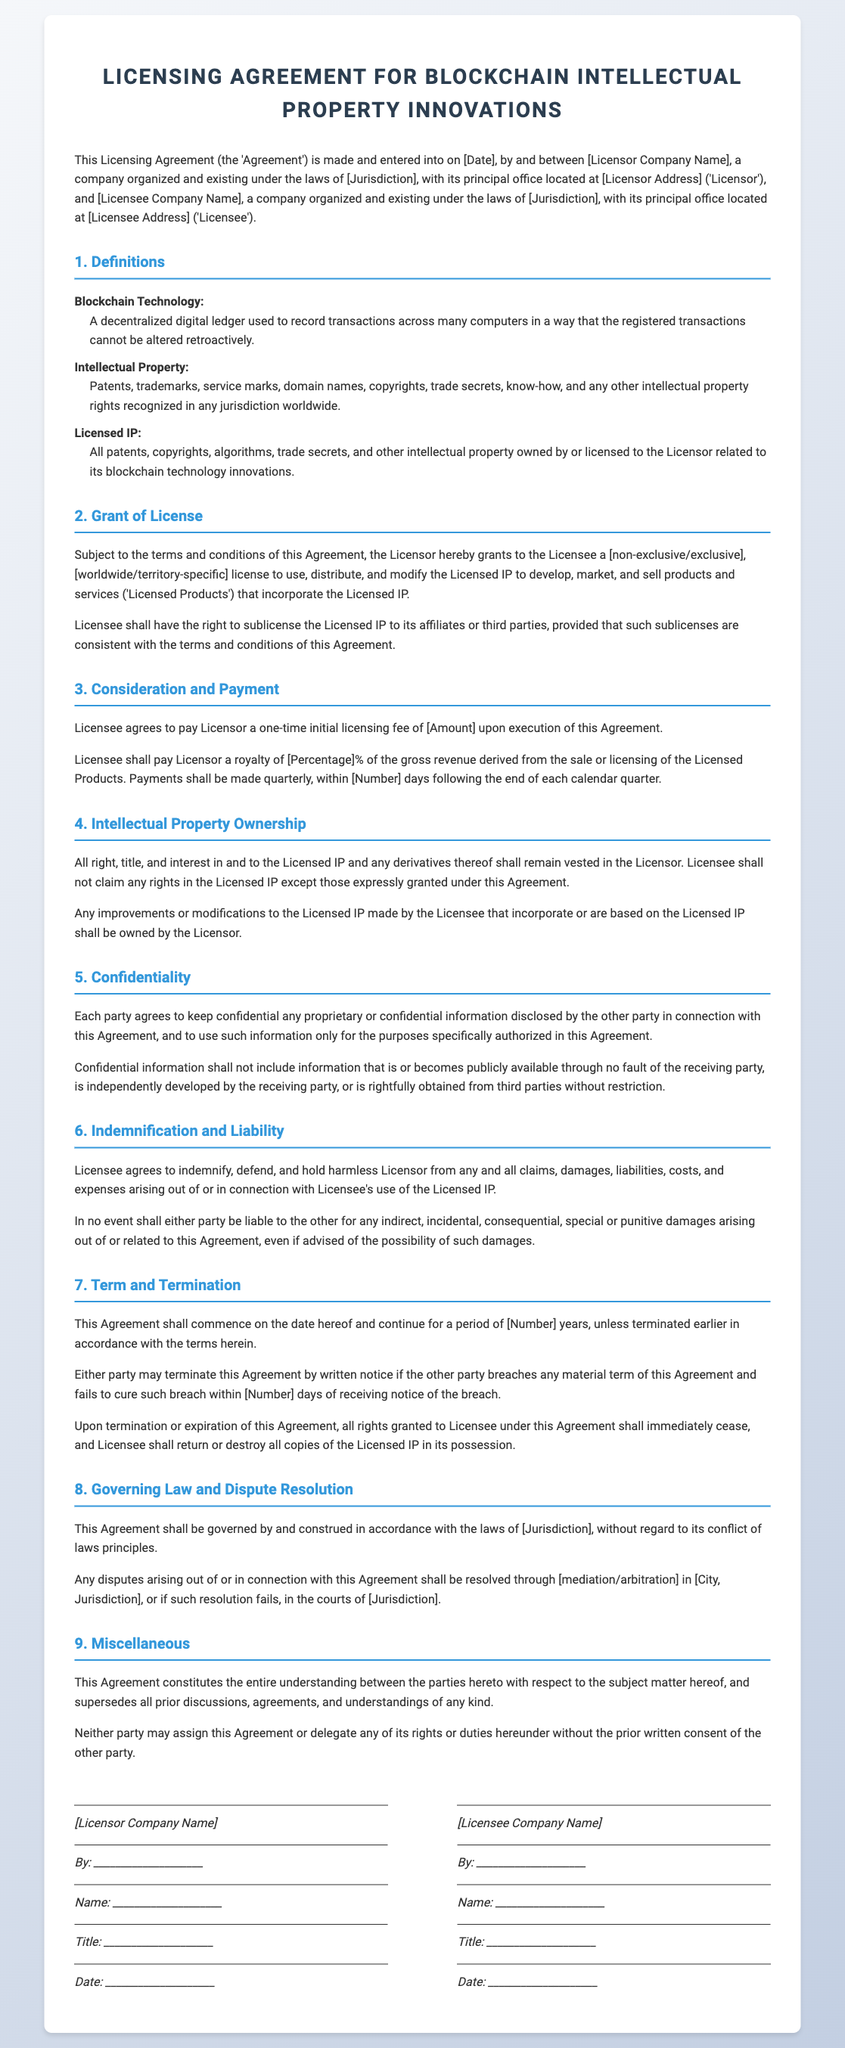what is the title of the document? The title of the document appears prominently at the top of the rendered contract.
Answer: Licensing Agreement for Blockchain Intellectual Property Innovations who are the parties involved in the Agreement? The document specifies the parties at the beginning under Licensor and Licensee.
Answer: Licensor Company Name and Licensee Company Name what is the initial licensing fee? The document mentions the fee under the Consideration and Payment section, indicating it's a single amount to be paid.
Answer: [Amount] how long is the term of the Agreement? The duration of the Agreement is specified in the Term and Termination section as a numeric timeframe.
Answer: [Number] years what type of license does the Licensor grant? This information is detailed in the Grant of License section, describing the nature of the license.
Answer: [non-exclusive/exclusive] what is the percentage of royalty payment? The document details the royalty structure in the Consideration and Payment section, specifying a percentage of revenue.
Answer: [Percentage]% what is included in the definition of Intellectual Property? The definition elaborates on various intellectual property rights recognized internationally.
Answer: Patents, trademarks, service marks, domain names, copyrights, trade secrets, know-how, and other intellectual property rights where does the Agreement establish the governing law? The governing law is mentioned in the Governing Law and Dispute Resolution section, specifying the legal jurisdiction.
Answer: [Jurisdiction] what happens upon termination of the Agreement? The document outlines actions required from both parties after termination or expiration.
Answer: All rights granted to Licensee shall immediately cease, and Licensee shall return or destroy all copies of the Licensed IP in its possession 